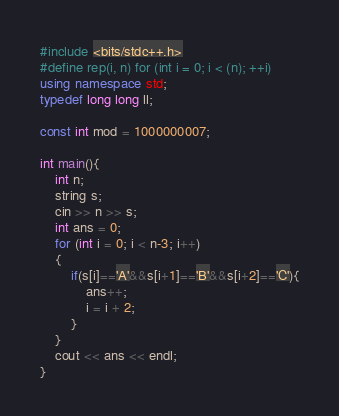<code> <loc_0><loc_0><loc_500><loc_500><_C++_>#include <bits/stdc++.h>
#define rep(i, n) for (int i = 0; i < (n); ++i)
using namespace std;
typedef long long ll;

const int mod = 1000000007;

int main(){
    int n;
    string s;
    cin >> n >> s;
    int ans = 0;
    for (int i = 0; i < n-3; i++)
    {
        if(s[i]=='A'&&s[i+1]=='B'&&s[i+2]=='C'){
            ans++;
            i = i + 2;
        }
    }
    cout << ans << endl;
}</code> 